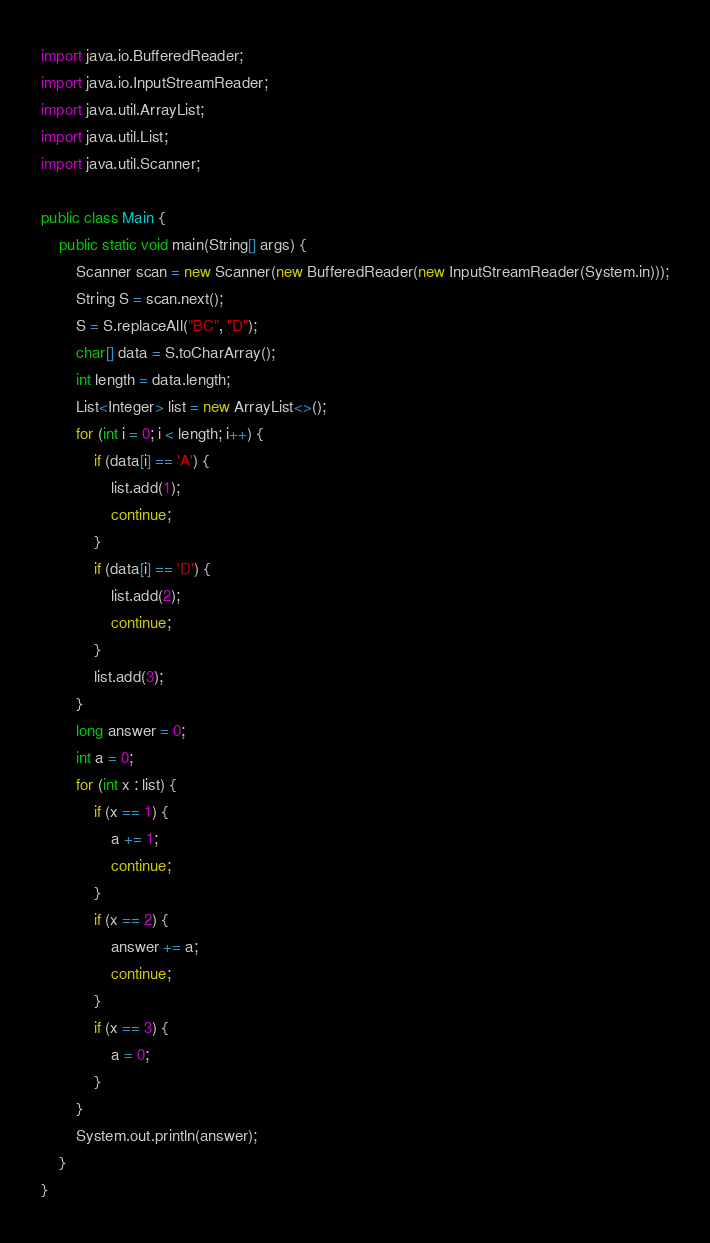Convert code to text. <code><loc_0><loc_0><loc_500><loc_500><_Java_>import java.io.BufferedReader;
import java.io.InputStreamReader;
import java.util.ArrayList;
import java.util.List;
import java.util.Scanner;

public class Main {
    public static void main(String[] args) {
        Scanner scan = new Scanner(new BufferedReader(new InputStreamReader(System.in)));
        String S = scan.next();
        S = S.replaceAll("BC", "D");
        char[] data = S.toCharArray();
        int length = data.length;
        List<Integer> list = new ArrayList<>();
        for (int i = 0; i < length; i++) {
            if (data[i] == 'A') {
                list.add(1);
                continue;
            }
            if (data[i] == 'D') {
                list.add(2);
                continue;
            }
            list.add(3);
        }
        long answer = 0;
        int a = 0;
        for (int x : list) {
            if (x == 1) {
                a += 1;
                continue;
            }
            if (x == 2) {
                answer += a;
                continue;
            }
            if (x == 3) {
                a = 0;
            }
        }
        System.out.println(answer);
    }
}
</code> 